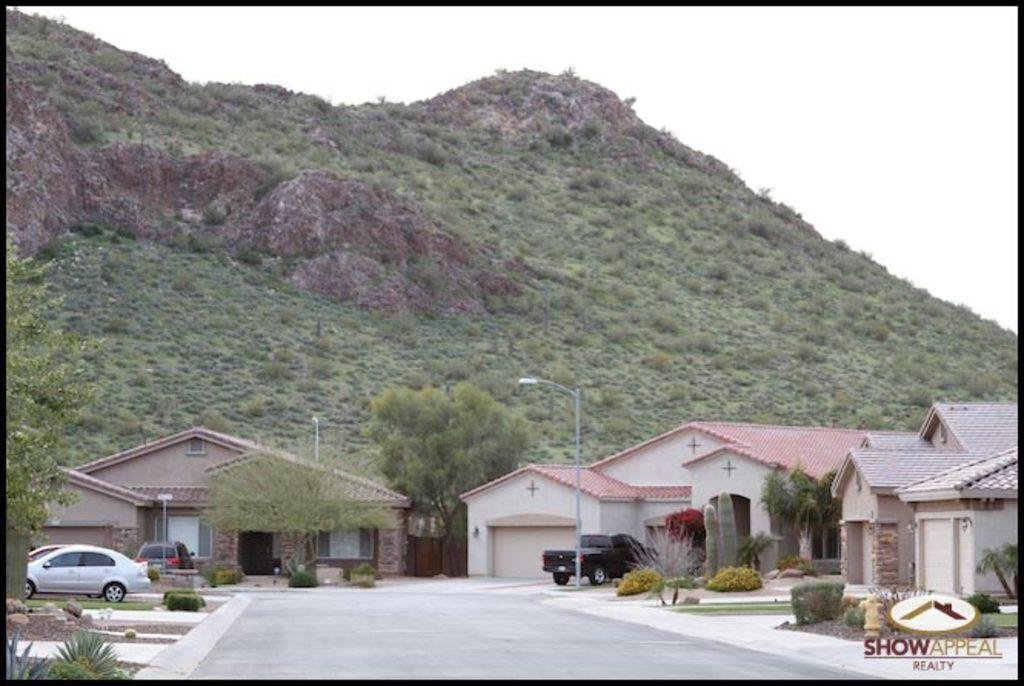What type of structures can be seen in the image? There are buildings in the image. What else can be seen near the buildings? There are cars parked near the buildings. What type of vegetation is present in the image? There are trees in the image. What can be seen on the footpath in the image? There are street light poles on the footpath. What type of beef is being served at the restaurant in the image? There is no restaurant or beef present in the image. What is the slope of the hill in the image? There is no hill or slope present in the image. 